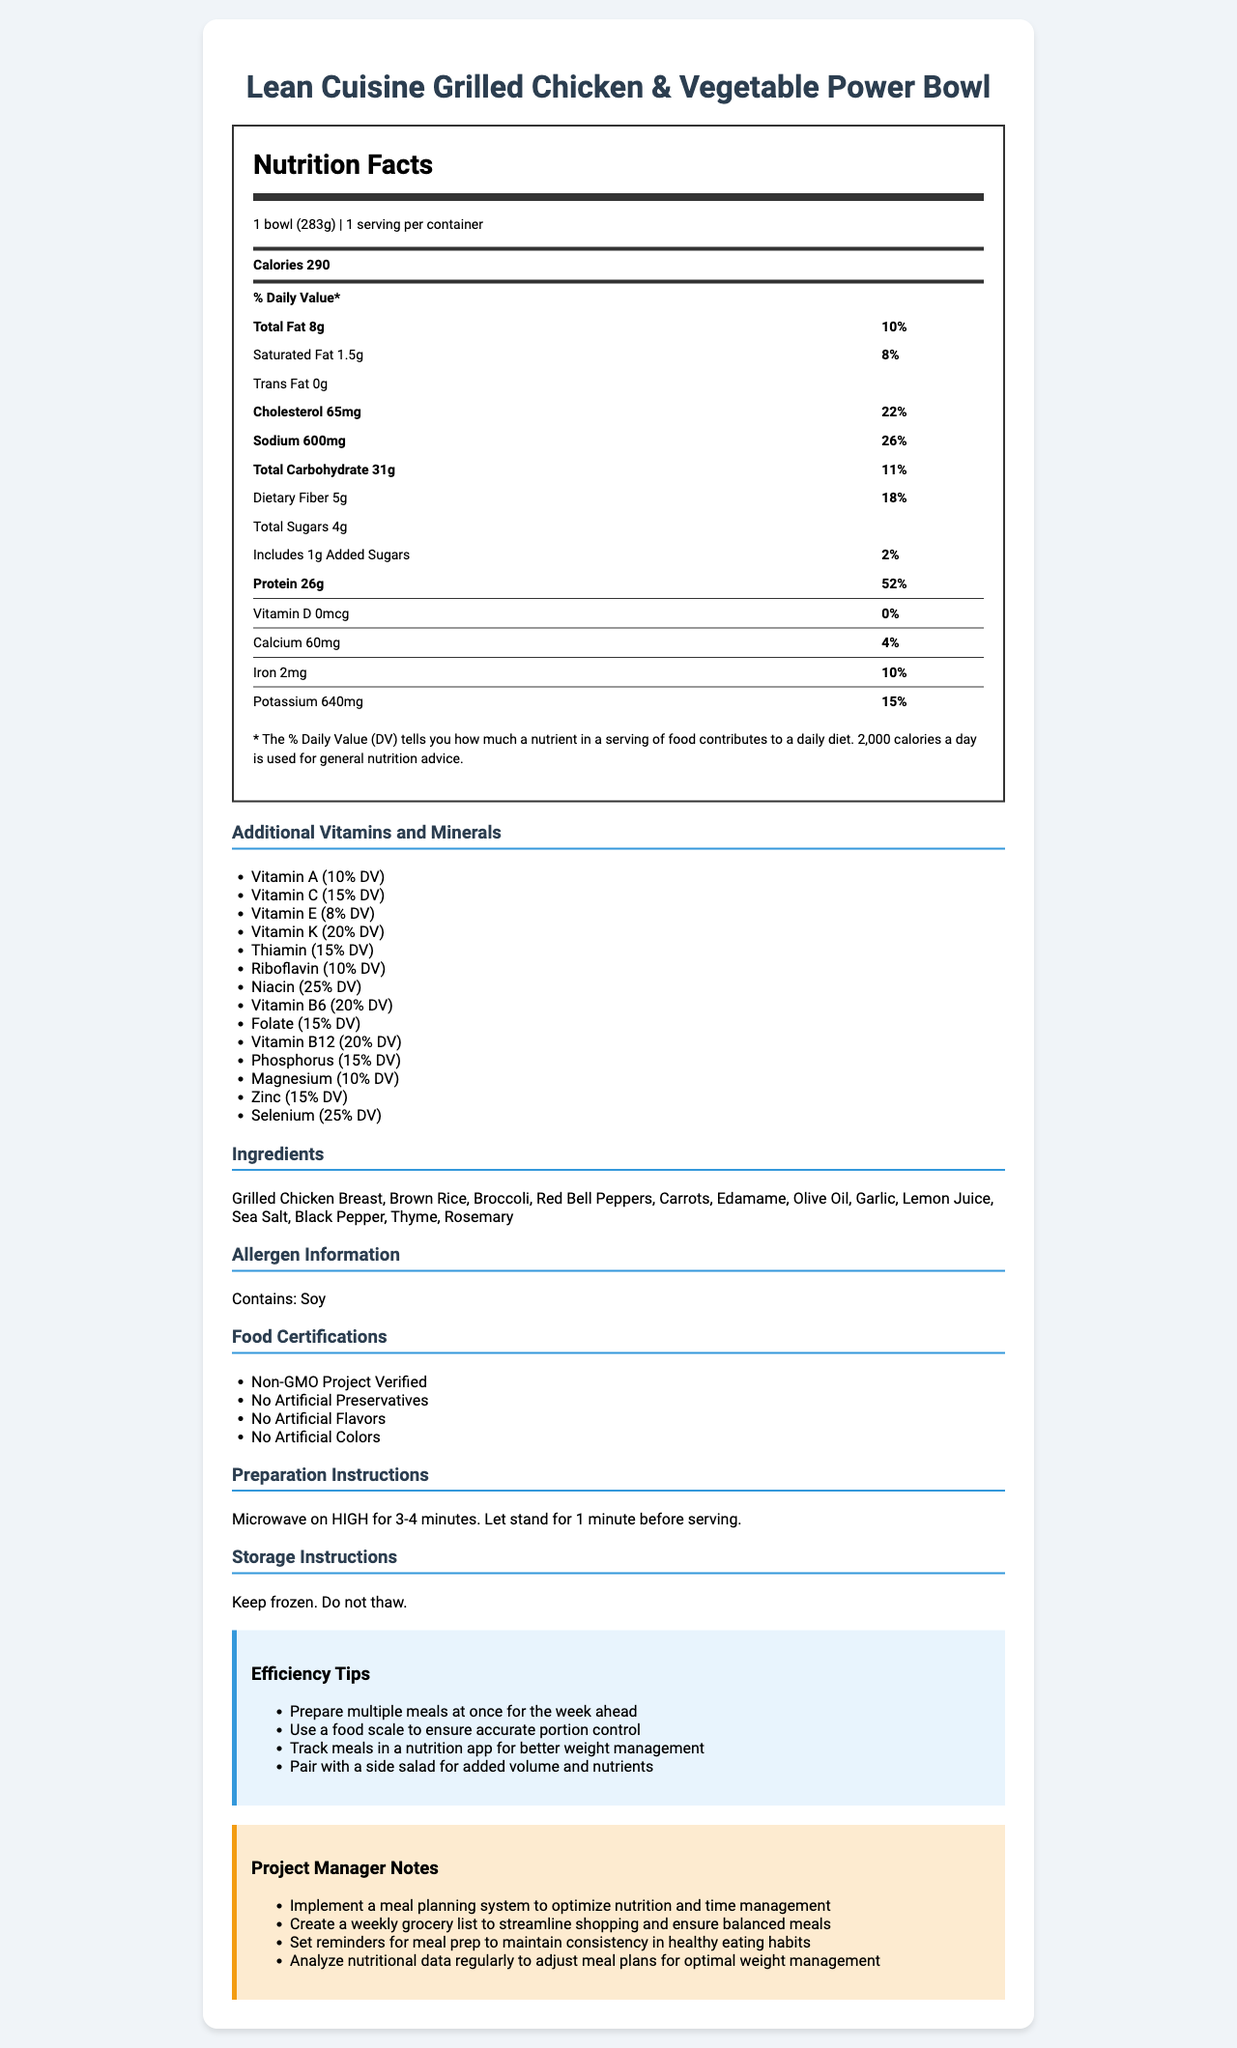what is the serving size? The serving size is listed at the top of the Nutrition Facts Label.
Answer: 1 bowl (283g) how many servings are in one container? The number of servings per container is mentioned next to the serving size.
Answer: 1 how many calories are in one serving? The calorie count is listed at the top of the Nutrition Facts Label.
Answer: 290 what is the daily value percentage of total fat? The daily value percentage is indicated next to the total fat amount.
Answer: 10% how much protein does this meal provide? The protein content is listed alongside the % Daily Value.
Answer: 26g how much sodium is in the meal? A. 300mg B. 500mg C. 600mg D. 700mg The sodium amount is clearly stated along with its % Daily Value.
Answer: C. 600mg how much dietary fiber is present in the meal? The dietary fiber amount is listed under the total carbohydrate section.
Answer: 5g which of the following certifications does the product have? I. Non-GMO Project Verified II. USDA Organic III. No Artificial Preservatives IV. Gluten-Free A. I, II, III B. I, III, IV C. I, III D. II, IV The food certifications listed include "Non-GMO Project Verified" and "No Artificial Preservatives".
Answer: C. I, III does the meal contain any trans fat? The trans fat amount is stated as 0g.
Answer: No describe the main idea of the document. The document is an all-encompassing guide to understanding the nutritional value and additional details of the specific frozen meal.
Answer: The document provides detailed nutritional information for the "Lean Cuisine Grilled Chicken & Vegetable Power Bowl," including serving size, calories, macronutrients, vitamins and minerals, ingredients, allergen information, food certifications, preparation and storage instructions, along with efficiency tips and project manager notes. is there any vitamin D in the meal? The amount of vitamin D is listed as 0mcg.
Answer: No what are the main ingredients in this meal? The ingredients section lists all the main ingredients used in the meal.
Answer: Grilled Chicken Breast, Brown Rice, Broccoli, Red Bell Peppers, Carrots, Edamame, Olive Oil, Garlic, Lemon Juice, Sea Salt, Black Pepper, Thyme, Rosemary what are the preparation instructions? The preparation instructions are given in the document.
Answer: Microwave on HIGH for 3-4 minutes. Let stand for 1 minute before serving. how much iron does this meal provide? The amount of iron is listed under the vitamins and minerals section.
Answer: 2mg what is the function of the fibers present in the meal? The document provides the fiber content but doesn't discuss its specific function.
Answer: Not enough information what is the allergen information for this meal? The allergen information clearly states that the meal contains soy.
Answer: Contains: Soy 